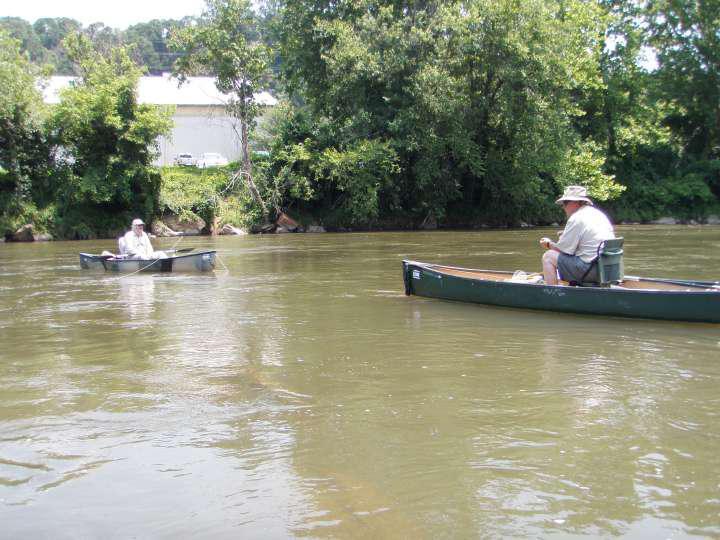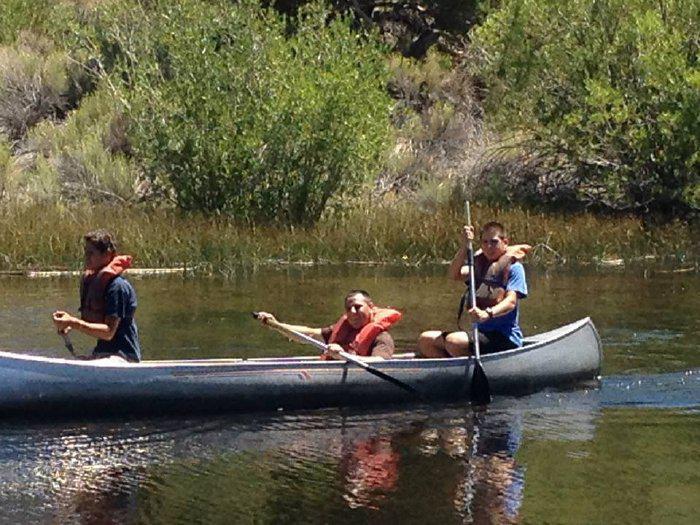The first image is the image on the left, the second image is the image on the right. Assess this claim about the two images: "Two canoes, each with one rider, are present in one image.". Correct or not? Answer yes or no. Yes. The first image is the image on the left, the second image is the image on the right. Given the left and right images, does the statement "There are no more than than two people in the image on the right." hold true? Answer yes or no. No. 